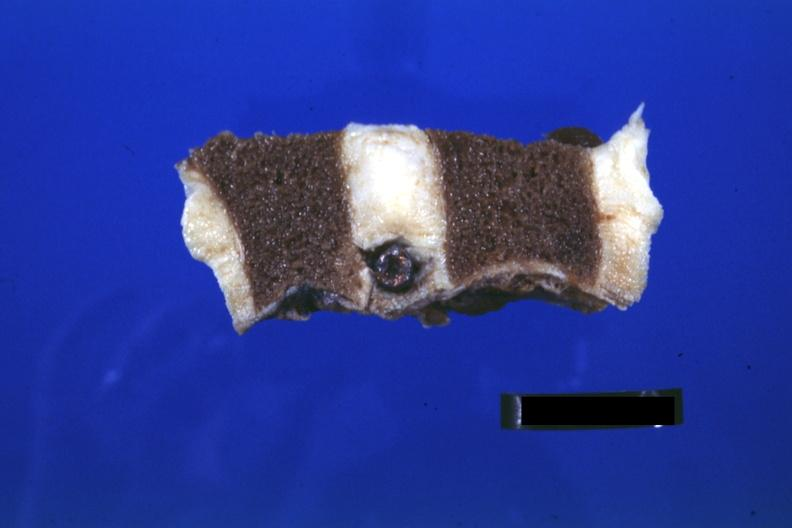s joints present?
Answer the question using a single word or phrase. Yes 